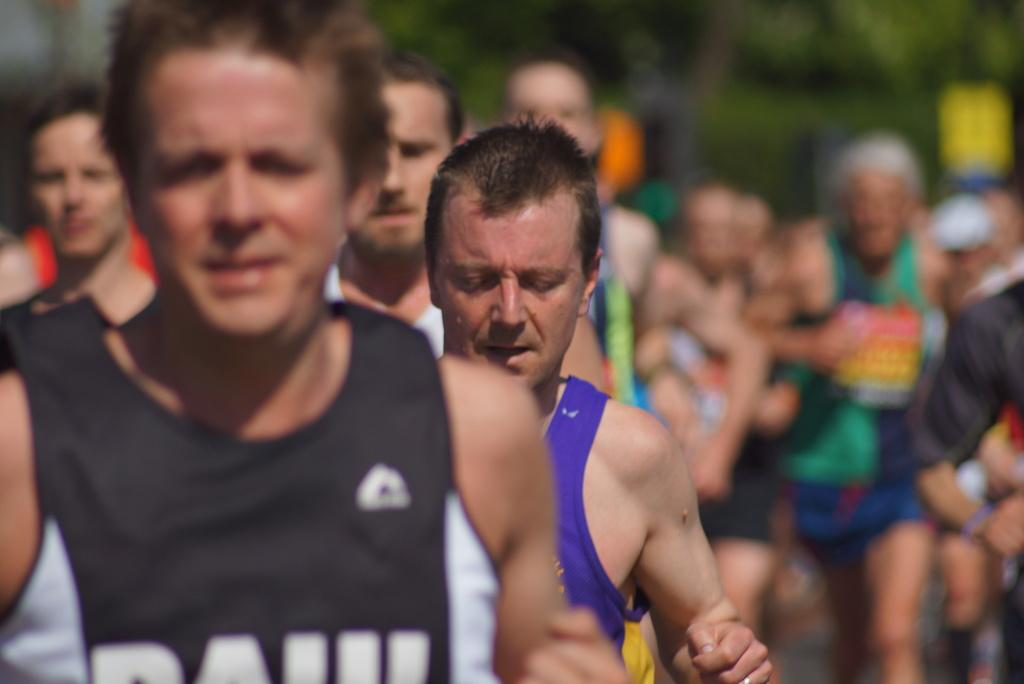What are the people in the image doing? The people in the image are running. Can you describe the background of the image? The background of the image is blurred. What type of jar can be seen next to the friend in the image? There is no jar or friend present in the image; it only shows people running with a blurred background. 